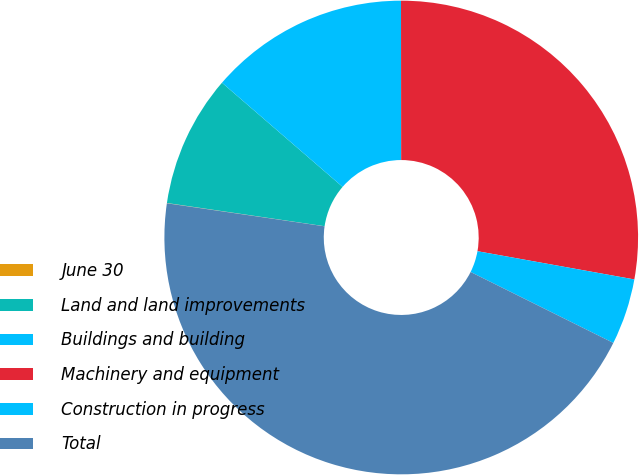Convert chart to OTSL. <chart><loc_0><loc_0><loc_500><loc_500><pie_chart><fcel>June 30<fcel>Land and land improvements<fcel>Buildings and building<fcel>Machinery and equipment<fcel>Construction in progress<fcel>Total<nl><fcel>0.02%<fcel>9.01%<fcel>13.65%<fcel>27.85%<fcel>4.51%<fcel>44.97%<nl></chart> 